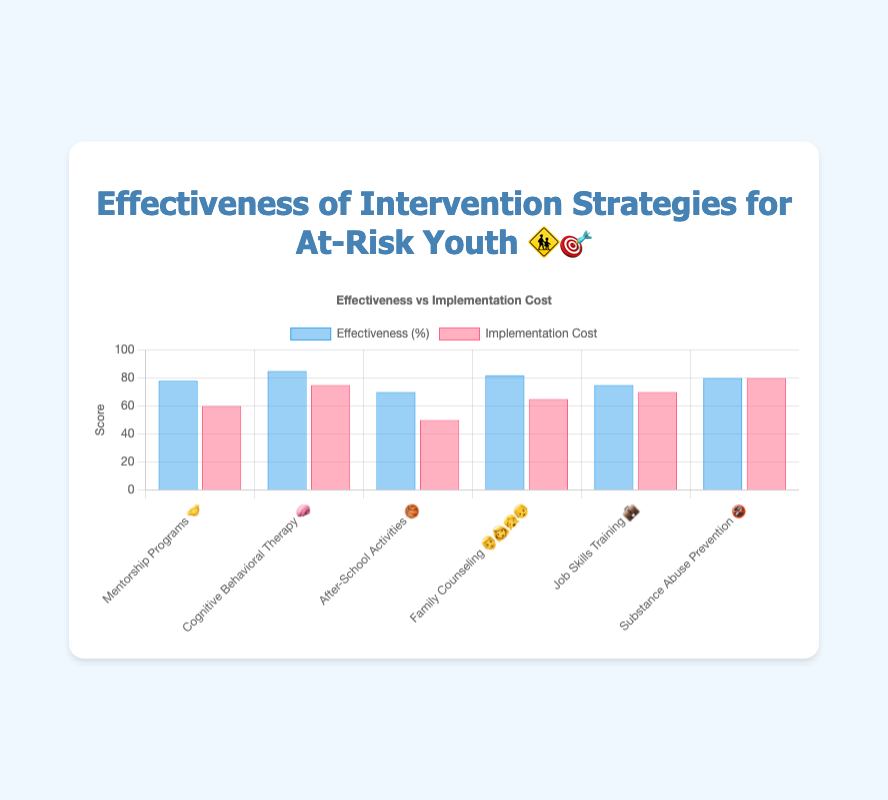Which intervention strategy has the highest effectiveness? The bar for 'Cognitive Behavioral Therapy 🧠' reaches the highest point in the effectiveness category at 85%
Answer: Cognitive Behavioral Therapy 🧠 Which intervention strategy has the lowest implementation cost? The bar for 'After-School Activities 🏀' is the shortest in the implementation cost category at 50
Answer: After-School Activities 🏀 What is the difference in effectiveness between the highest and lowest strategies? The highest effectiveness is for 'Cognitive Behavioral Therapy 🧠' at 85%, and the lowest is for 'After-School Activities 🏀' at 70%. The difference is 85 - 70 = 15%
Answer: 15% Which intervention strategy has the highest implementation cost and what is its effectiveness? The 'Substance Abuse Prevention 🚭' strategy has the highest implementation cost at 80. Its effectiveness is 80%
Answer: Substance Abuse Prevention 🚭, 80% What is the average effectiveness of all intervention strategies? The effectiveness values are 78, 85, 70, 82, 75, and 80. Average is (78 + 85 + 70 + 82 + 75 + 80) / 6 = 78.33
Answer: 78.33% Which intervention strategy is ranked third in terms of effectiveness? After listing the effectiveness values in descending order (85, 82, 80, 78, 75, 70), the third highest is 'Substance Abuse Prevention 🚭' with 80%
Answer: Substance Abuse Prevention 🚭 Is there any intervention strategy where the implementation cost is higher than its effectiveness? By comparing both values for all strategies, none of the implementation costs are higher than their effectiveness values
Answer: No How many intervention strategies have an effectiveness rate of 80% or higher? The strategies with effectiveness rates of 80% or higher are 'Cognitive Behavioral Therapy 🧠' (85%), 'Family Counseling 👨‍👩‍👧‍👦' (82%), and 'Substance Abuse Prevention 🚭' (80%). There are 3 such strategies
Answer: 3 Which intervention strategy could be considered the most cost-effective? 'Mentorship Programs 🤝' has a high effectiveness (78%) for a relatively lower implementation cost (60) compared to other strategies
Answer: Mentorship Programs 🤝 